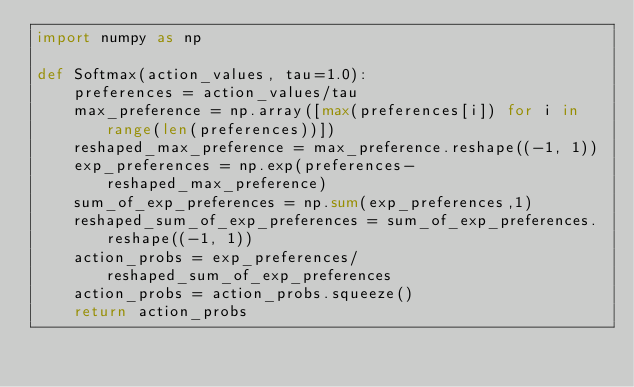<code> <loc_0><loc_0><loc_500><loc_500><_Python_>import numpy as np

def Softmax(action_values, tau=1.0):
    preferences = action_values/tau
    max_preference = np.array([max(preferences[i]) for i in range(len(preferences))])
    reshaped_max_preference = max_preference.reshape((-1, 1))
    exp_preferences = np.exp(preferences-reshaped_max_preference)
    sum_of_exp_preferences = np.sum(exp_preferences,1)
    reshaped_sum_of_exp_preferences = sum_of_exp_preferences.reshape((-1, 1))
    action_probs = exp_preferences/reshaped_sum_of_exp_preferences
    action_probs = action_probs.squeeze()
    return action_probs</code> 